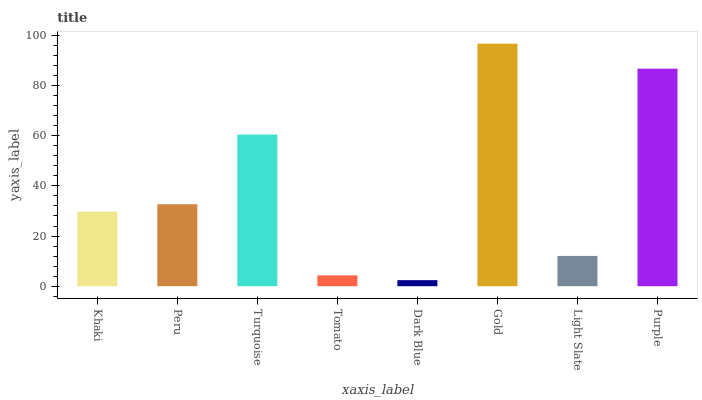Is Dark Blue the minimum?
Answer yes or no. Yes. Is Gold the maximum?
Answer yes or no. Yes. Is Peru the minimum?
Answer yes or no. No. Is Peru the maximum?
Answer yes or no. No. Is Peru greater than Khaki?
Answer yes or no. Yes. Is Khaki less than Peru?
Answer yes or no. Yes. Is Khaki greater than Peru?
Answer yes or no. No. Is Peru less than Khaki?
Answer yes or no. No. Is Peru the high median?
Answer yes or no. Yes. Is Khaki the low median?
Answer yes or no. Yes. Is Khaki the high median?
Answer yes or no. No. Is Peru the low median?
Answer yes or no. No. 